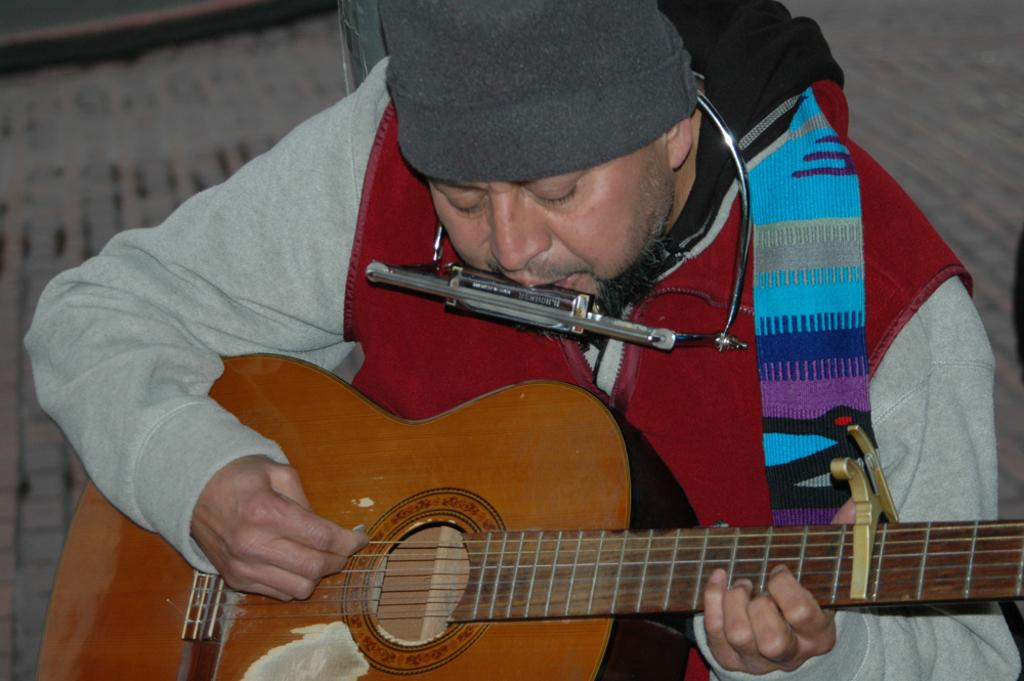What is the man in the image doing? The man is playing a harmonium and a guitar in the image. What type of clothing is the man wearing? The man is wearing a red color jacket. What type of authority does the man have in the image? There is no indication of the man having any authority in the image. Can you see any ducks in the image? There are no ducks present in the image. 